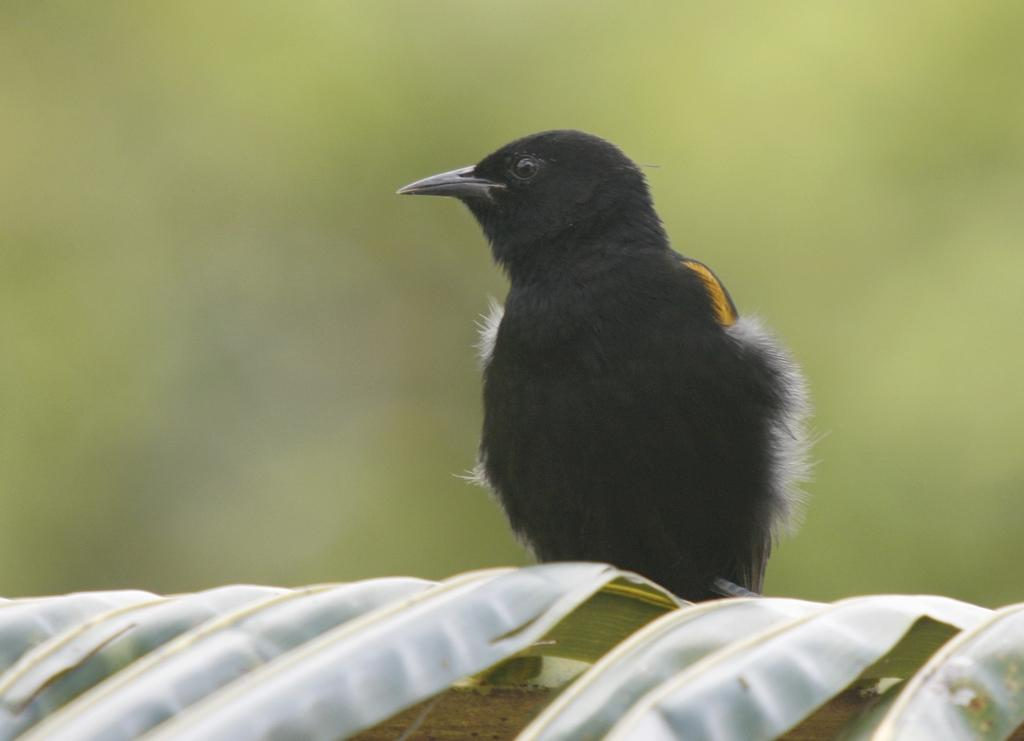What type of animal can be seen in the image? There is a black bird present in the image. Where is the black bird located? The black bird is sitting on a branch. What is the branch a part of? The branch is part of a tree. What is the color of the leaves on the tree? The tree has green leaves. What type of vacation is the black bird planning in the image? There is no indication in the image that the black bird is planning a vacation, as it is simply sitting on a branch. Can you see any gold thread on the black bird in the image? There is no gold thread present on the black bird in the image. 